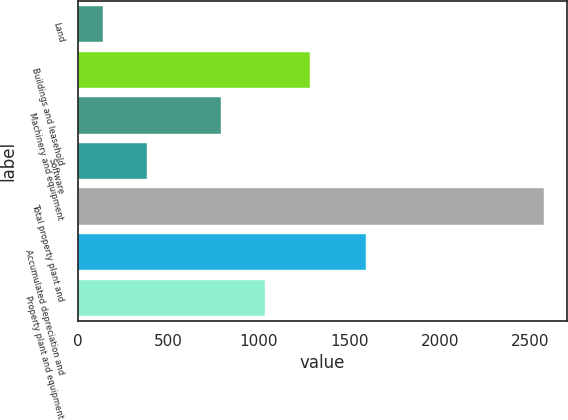<chart> <loc_0><loc_0><loc_500><loc_500><bar_chart><fcel>Land<fcel>Buildings and leasehold<fcel>Machinery and equipment<fcel>Software<fcel>Total property plant and<fcel>Accumulated depreciation and<fcel>Property plant and equipment<nl><fcel>137<fcel>1280.6<fcel>793<fcel>380.8<fcel>2575<fcel>1595<fcel>1036.8<nl></chart> 